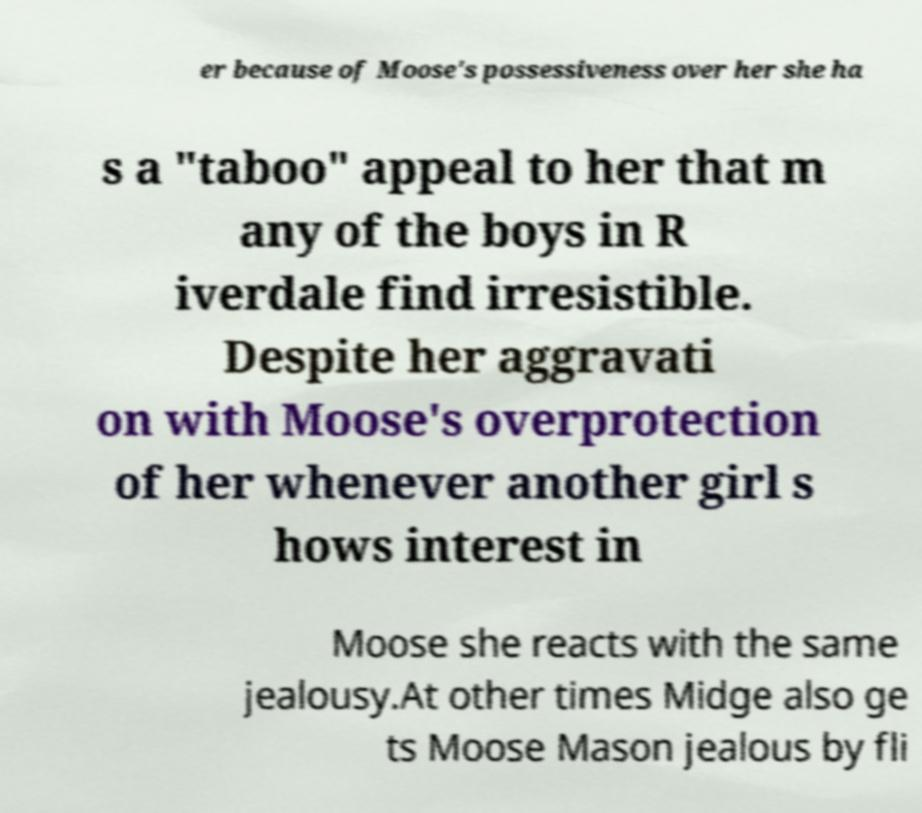Can you read and provide the text displayed in the image?This photo seems to have some interesting text. Can you extract and type it out for me? er because of Moose's possessiveness over her she ha s a "taboo" appeal to her that m any of the boys in R iverdale find irresistible. Despite her aggravati on with Moose's overprotection of her whenever another girl s hows interest in Moose she reacts with the same jealousy.At other times Midge also ge ts Moose Mason jealous by fli 